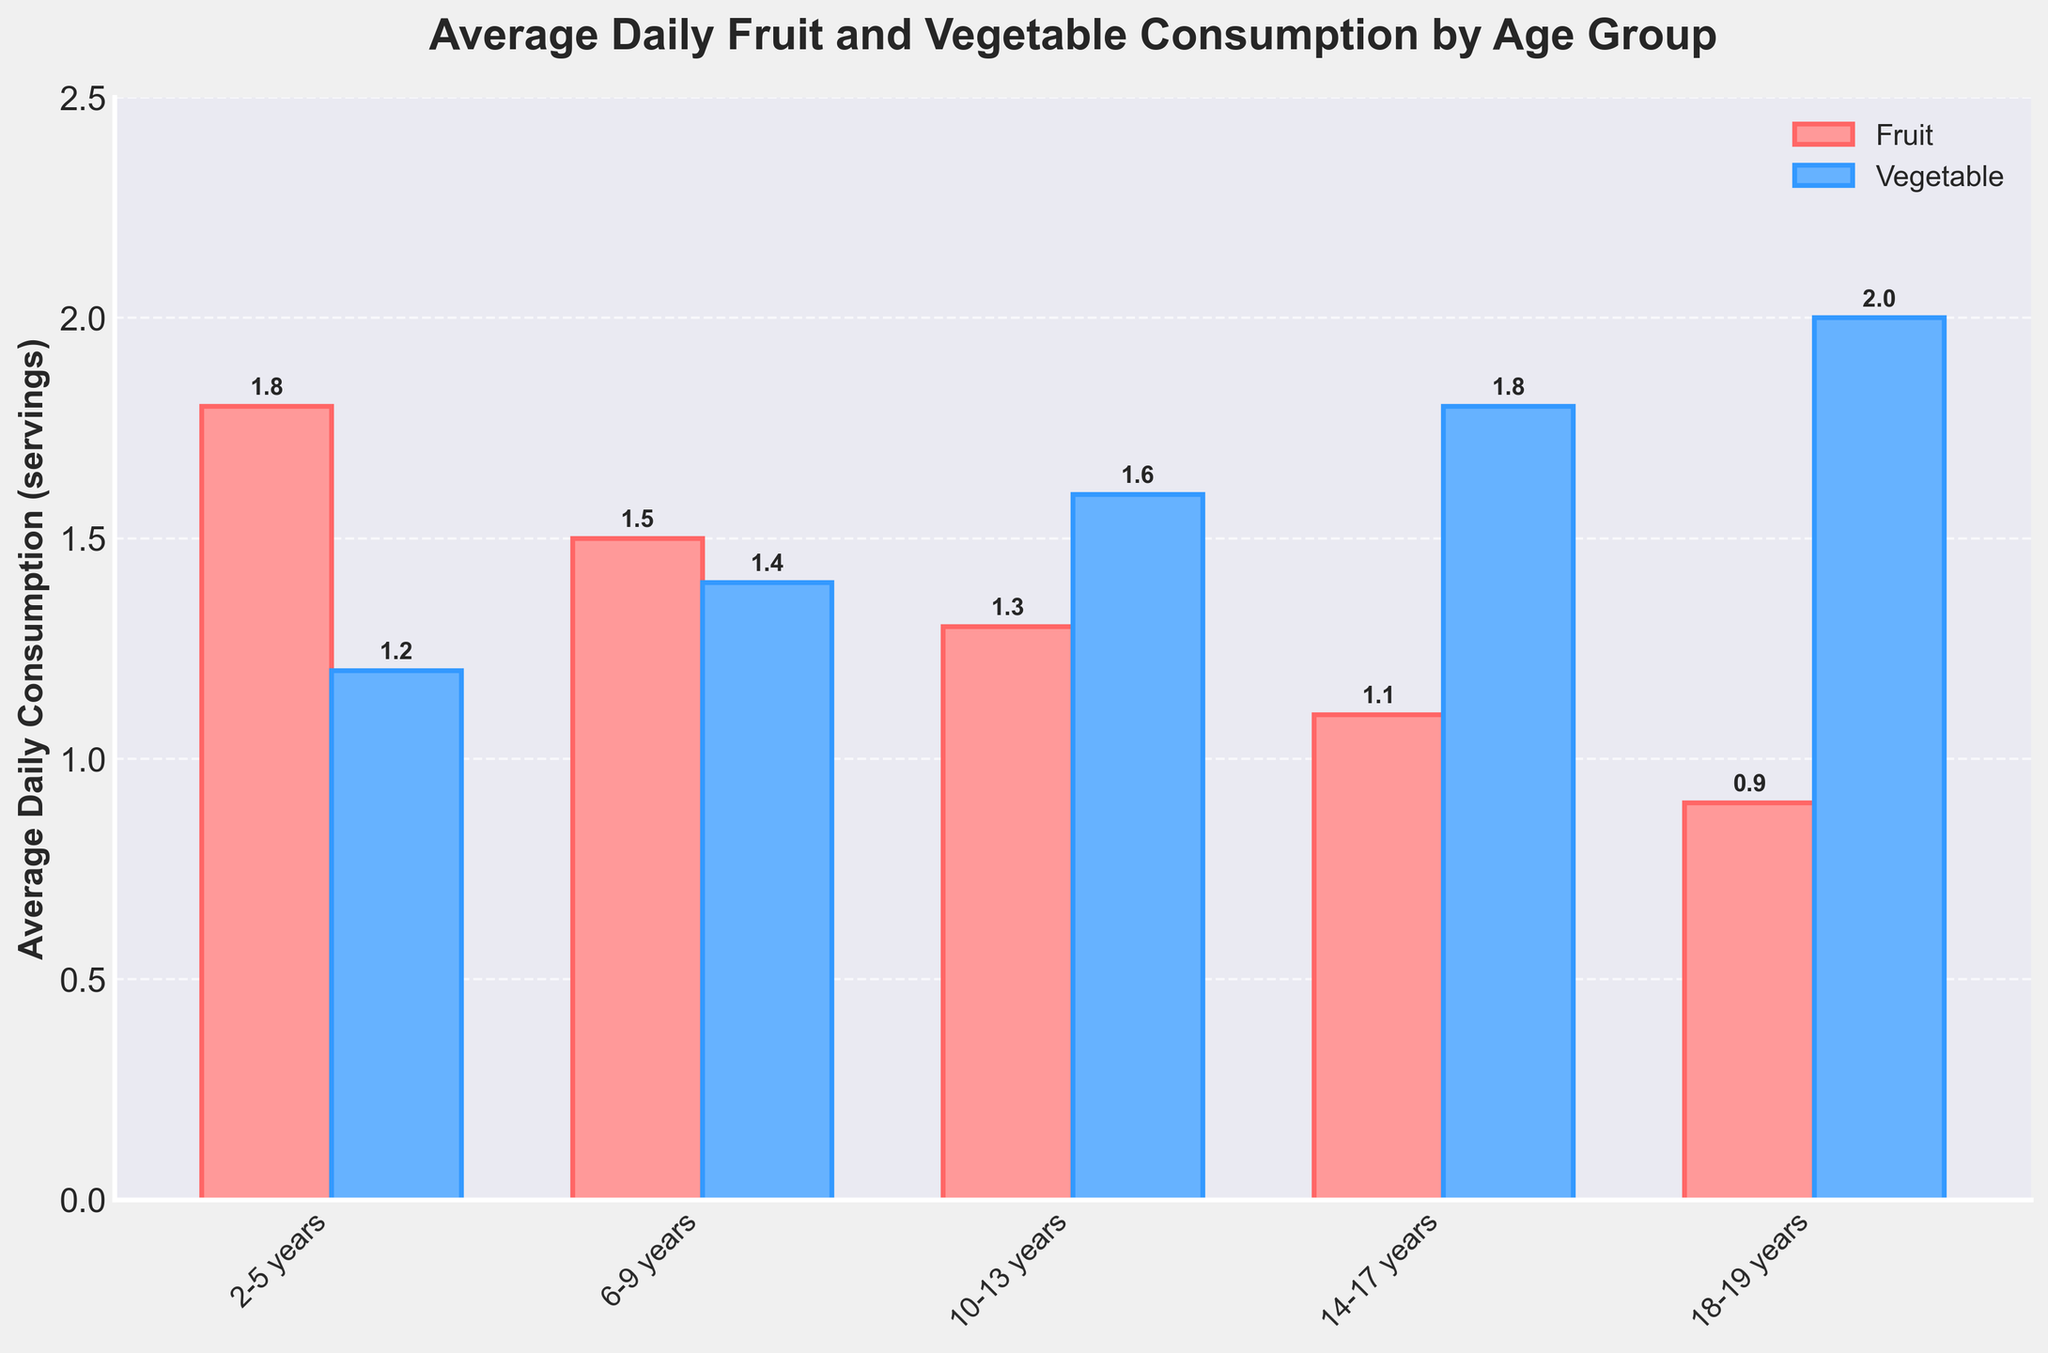What age group has the highest average daily vegetable consumption? By examining the bar heights in the vegetable consumption category, the age group with the highest bar is 18-19 years.
Answer: 18-19 years What is the difference in average daily fruit consumption between the 2-5 years and 18-19 years age groups? The average daily fruit consumption for the 2-5 years age group is 1.8 servings, and for the 18-19 years age group, it is 0.9 servings. The difference is 1.8 - 0.9 = 0.9 servings.
Answer: 0.9 servings Which age group consumes more vegetables than fruits? By comparing the heights of the bars for each age group, we see that the age groups 10-13 years, 14-17 years, and 18-19 years have higher vegetable consumption bars than fruit consumption bars.
Answer: 10-13 years, 14-17 years, 18-19 years What is the total average daily consumption of fruits and vegetables for the 6-9 years age group? The average daily fruit consumption for the 6-9 years age group is 1.5 servings, and the vegetable consumption is 1.4 servings. The total is 1.5 + 1.4 = 2.9 servings.
Answer: 2.9 servings Between which age groups is the drop in average daily fruit consumption the greatest? The differences in fruit consumption between successive age groups are calculated: 
2-5 to 6-9: 1.8 - 1.5 = 0.3 servings
6-9 to 10-13: 1.5 - 1.3 = 0.2 servings
10-13 to 14-17: 1.3 - 1.1 = 0.2 servings
14-17 to 18-19: 1.1 - 0.9 = 0.2 servings
The greatest drop is from 2-5 to 6-9 years.
Answer: 2-5 to 6-9 years Which age group has the closest average daily consumption of fruits and vegetables? By comparing the height of the fruit and vegetable bars for each age group, the 6-9 years age group has the closest values with fruit consumption at 1.5 servings and vegetable consumption at 1.4 servings.
Answer: 6-9 years How many age groups consume at least 1.5 servings of vegetables daily? The age groups with vegetable consumption bars at or above the 1.5 level are 10-13 years, 14-17 years, and 18-19 years.
Answer: 3 What is the average daily fruit consumption across all age groups? The average daily fruit consumption for each age group is summed: 1.8 + 1.5 + 1.3 + 1.1 + 0.9 = 6.6 servings. Then divide by the number of age groups (5): 6.6 / 5 = 1.32 servings.
Answer: 1.32 servings In which age group does vegetable consumption exceed fruit consumption by exactly 0.5 servings? By examining the differences between vegetable and fruit consumption for each age group:
2-5 years: 1.2 - 1.8 = -0.6
6-9 years: 1.4 - 1.5 = -0.1
10-13 years: 1.6 - 1.3 = 0.3
14-17 years: 1.8 - 1.1 = 0.7
18-19 years: 2.0 - 0.9 = 1.1
No age group has a difference of exactly 0.5 servings.
Answer: None 